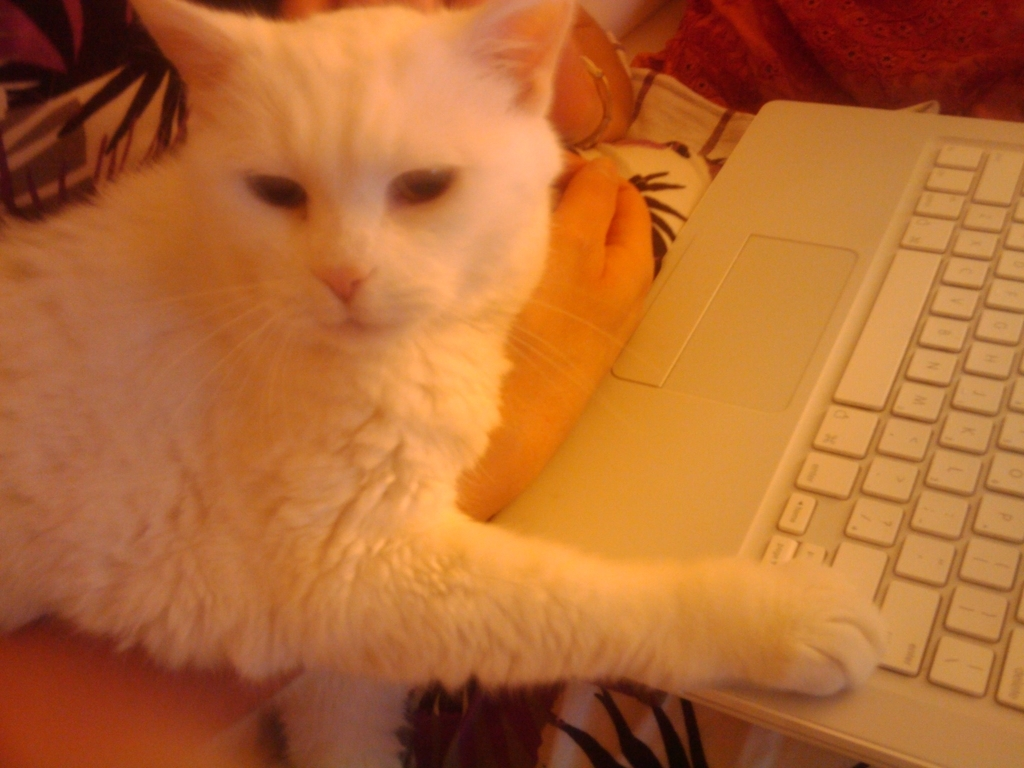Can you describe the environment or the items surrounding the cat? Certainly! The cat is pictured in an indoor setting, positioned next to a laptop on a desk, which suggests the owner might be working or studying. There is a visible human hand, indicating the presence of someone else, possibly the cat owner. The background includes textiles with different patterns, signaling a casual and comfortable home environment. 